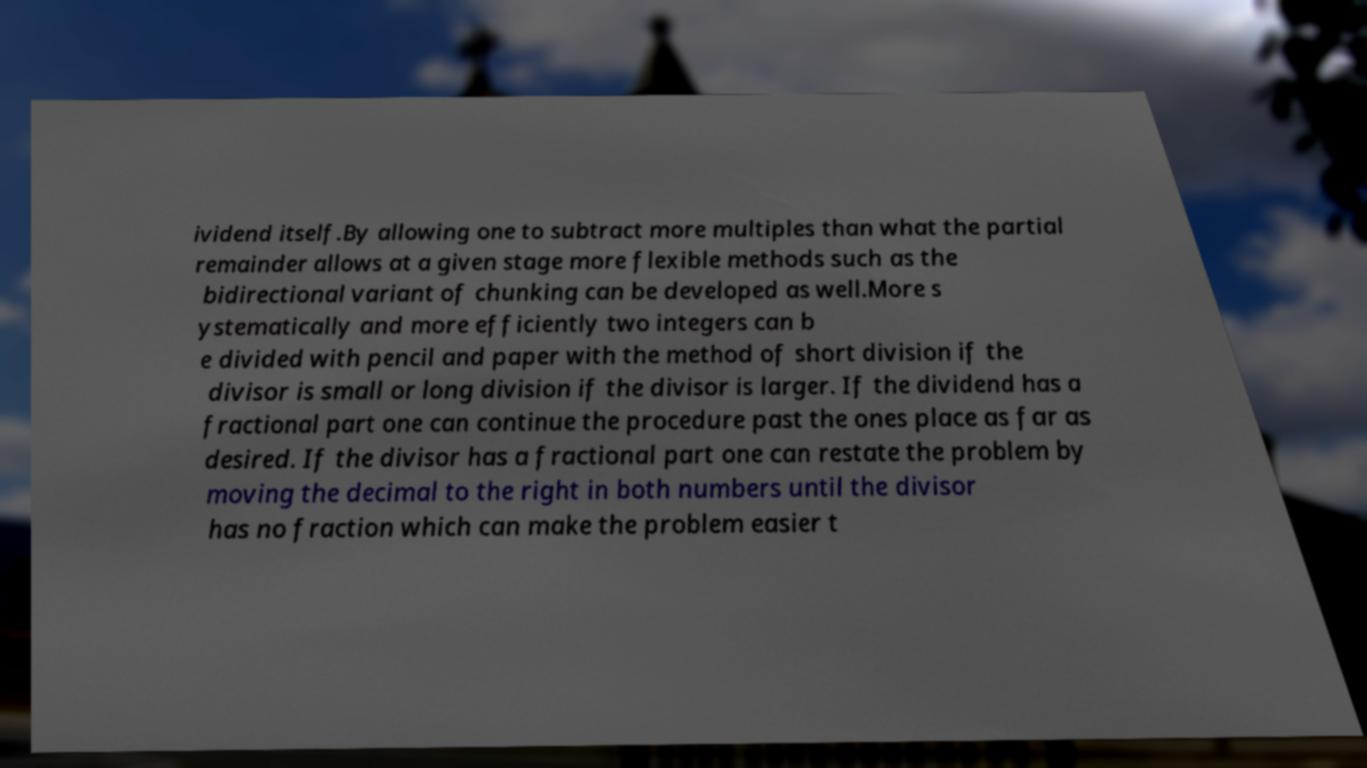Could you extract and type out the text from this image? ividend itself.By allowing one to subtract more multiples than what the partial remainder allows at a given stage more flexible methods such as the bidirectional variant of chunking can be developed as well.More s ystematically and more efficiently two integers can b e divided with pencil and paper with the method of short division if the divisor is small or long division if the divisor is larger. If the dividend has a fractional part one can continue the procedure past the ones place as far as desired. If the divisor has a fractional part one can restate the problem by moving the decimal to the right in both numbers until the divisor has no fraction which can make the problem easier t 